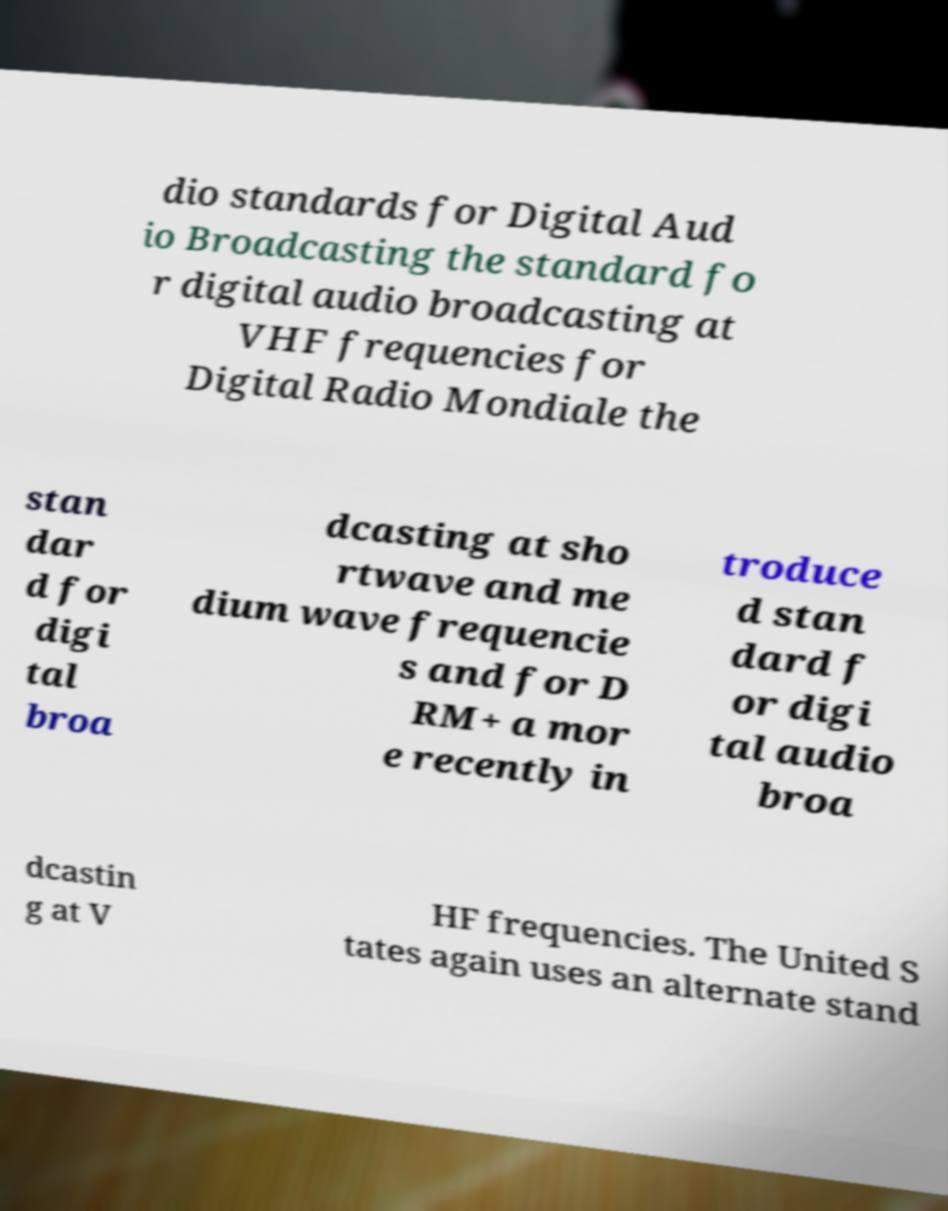What messages or text are displayed in this image? I need them in a readable, typed format. dio standards for Digital Aud io Broadcasting the standard fo r digital audio broadcasting at VHF frequencies for Digital Radio Mondiale the stan dar d for digi tal broa dcasting at sho rtwave and me dium wave frequencie s and for D RM+ a mor e recently in troduce d stan dard f or digi tal audio broa dcastin g at V HF frequencies. The United S tates again uses an alternate stand 